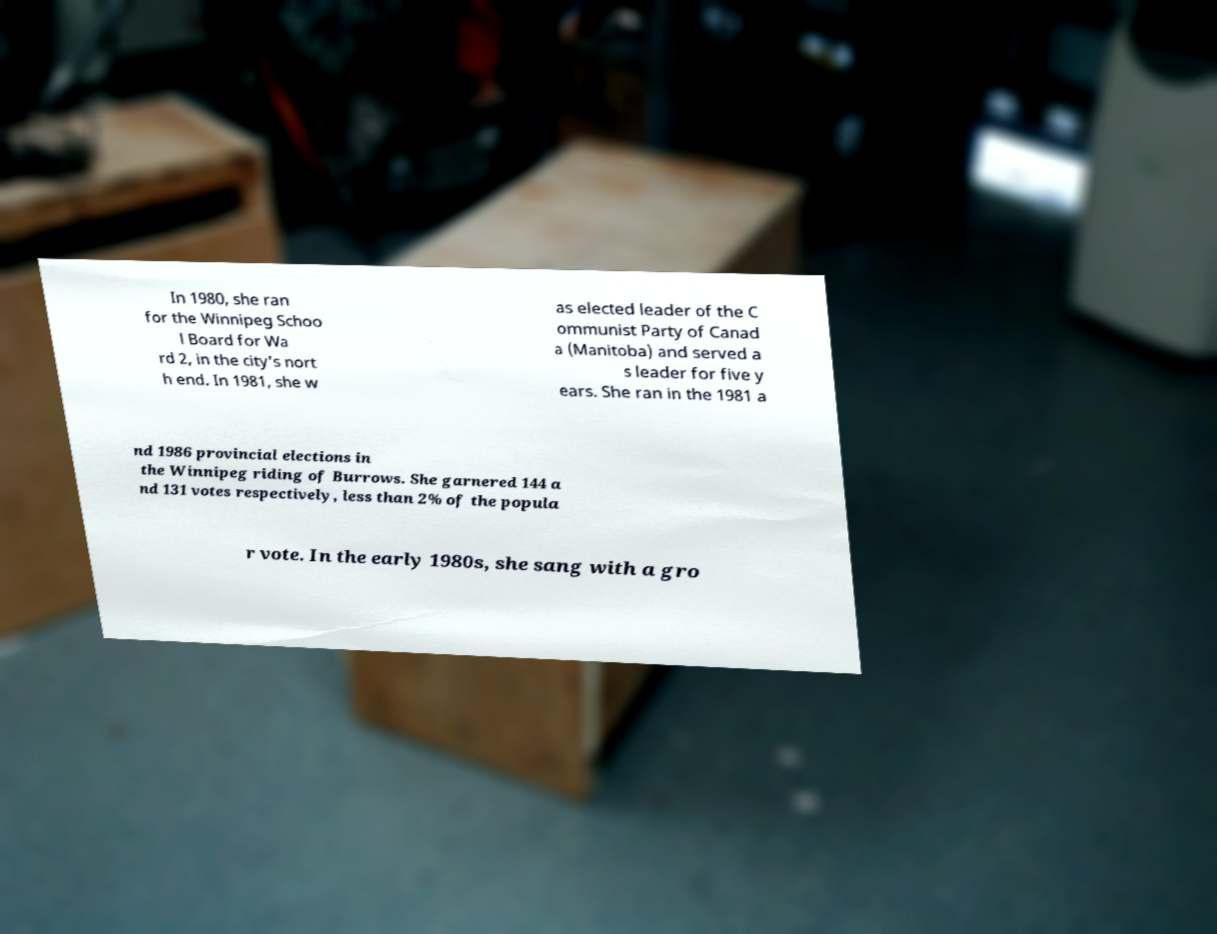For documentation purposes, I need the text within this image transcribed. Could you provide that? In 1980, she ran for the Winnipeg Schoo l Board for Wa rd 2, in the city's nort h end. In 1981, she w as elected leader of the C ommunist Party of Canad a (Manitoba) and served a s leader for five y ears. She ran in the 1981 a nd 1986 provincial elections in the Winnipeg riding of Burrows. She garnered 144 a nd 131 votes respectively, less than 2% of the popula r vote. In the early 1980s, she sang with a gro 